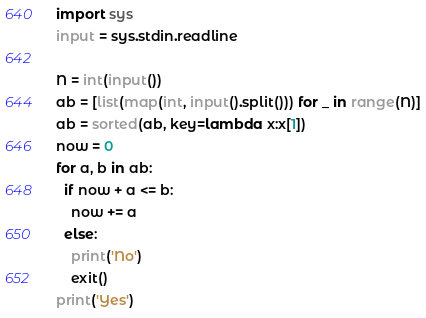<code> <loc_0><loc_0><loc_500><loc_500><_Python_>import sys
input = sys.stdin.readline

N = int(input())
ab = [list(map(int, input().split())) for _ in range(N)]
ab = sorted(ab, key=lambda x:x[1])
now = 0
for a, b in ab:
  if now + a <= b:
    now += a
  else:
    print('No')
    exit()
print('Yes')</code> 